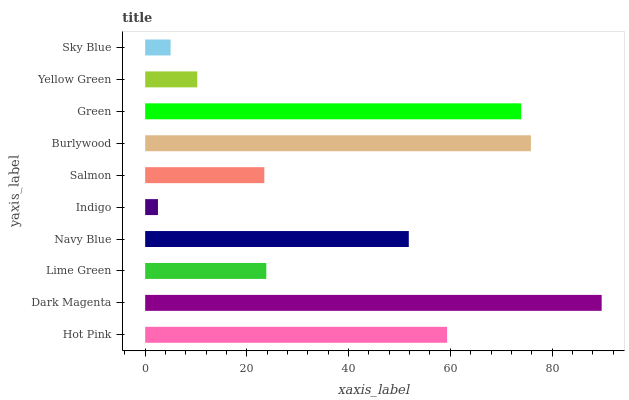Is Indigo the minimum?
Answer yes or no. Yes. Is Dark Magenta the maximum?
Answer yes or no. Yes. Is Lime Green the minimum?
Answer yes or no. No. Is Lime Green the maximum?
Answer yes or no. No. Is Dark Magenta greater than Lime Green?
Answer yes or no. Yes. Is Lime Green less than Dark Magenta?
Answer yes or no. Yes. Is Lime Green greater than Dark Magenta?
Answer yes or no. No. Is Dark Magenta less than Lime Green?
Answer yes or no. No. Is Navy Blue the high median?
Answer yes or no. Yes. Is Lime Green the low median?
Answer yes or no. Yes. Is Hot Pink the high median?
Answer yes or no. No. Is Burlywood the low median?
Answer yes or no. No. 